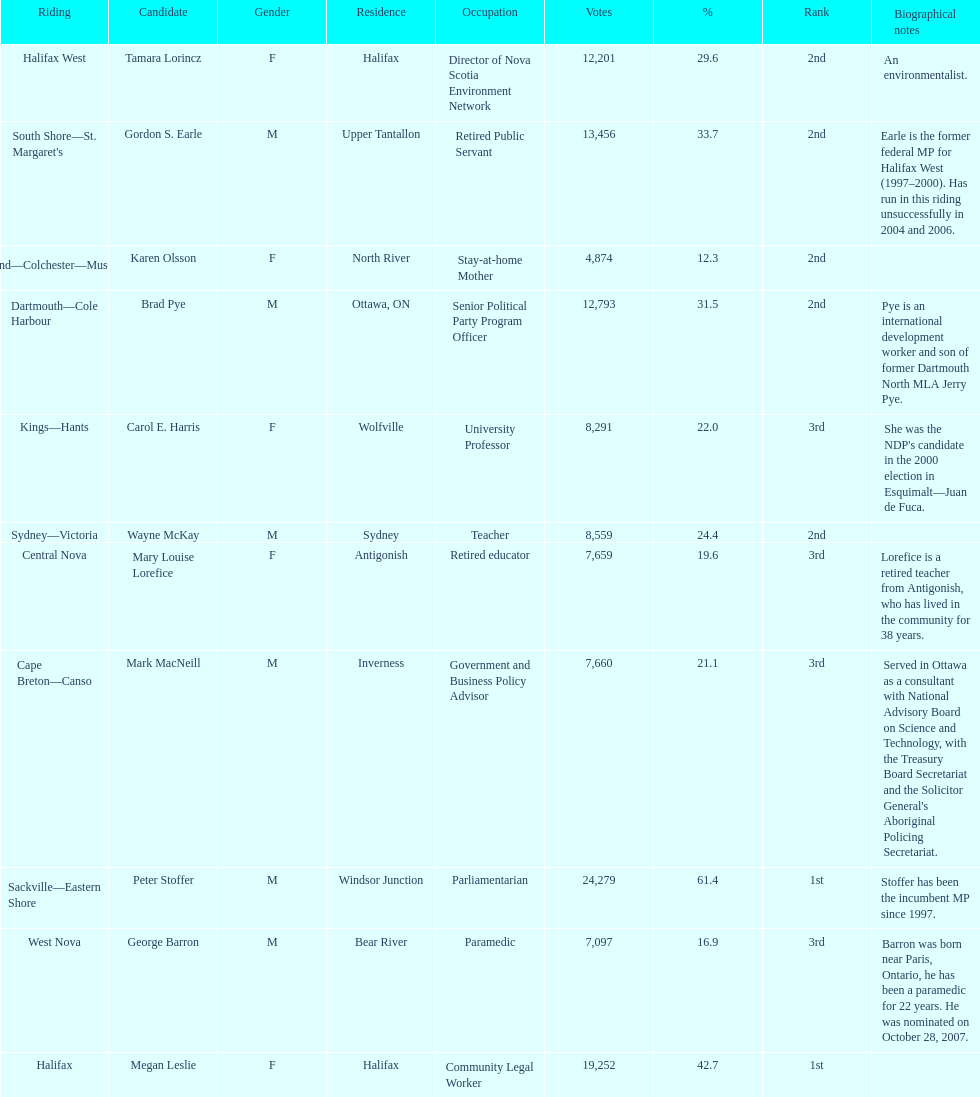Who received the least amount of votes? Karen Olsson. 